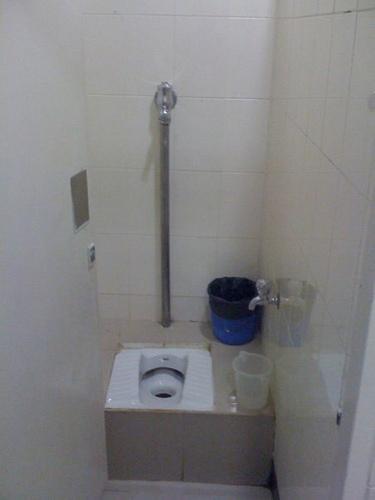How many toilets are there?
Give a very brief answer. 1. How many people are standing up?
Give a very brief answer. 0. 